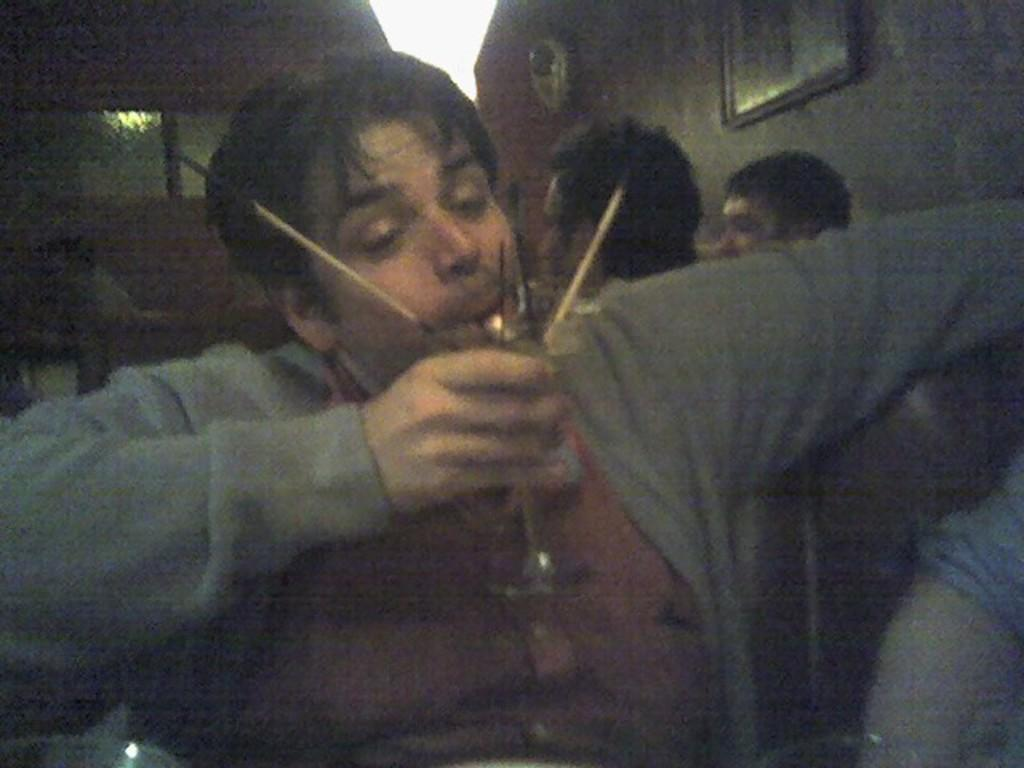What is the man in the image doing? The man is sitting in the image. What is the man holding in the image? The man is holding a glass in the image. Can you describe the people in the background of the image? There are people sitting in the background of the image. What type of chalk is being used to draw on the volcano in the image? There is no chalk or volcano present in the image. 